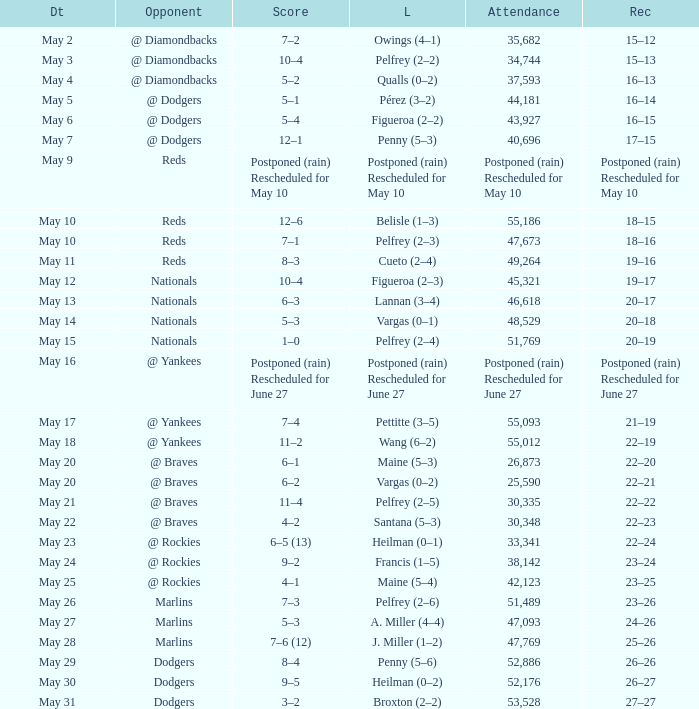Could you help me parse every detail presented in this table? {'header': ['Dt', 'Opponent', 'Score', 'L', 'Attendance', 'Rec'], 'rows': [['May 2', '@ Diamondbacks', '7–2', 'Owings (4–1)', '35,682', '15–12'], ['May 3', '@ Diamondbacks', '10–4', 'Pelfrey (2–2)', '34,744', '15–13'], ['May 4', '@ Diamondbacks', '5–2', 'Qualls (0–2)', '37,593', '16–13'], ['May 5', '@ Dodgers', '5–1', 'Pérez (3–2)', '44,181', '16–14'], ['May 6', '@ Dodgers', '5–4', 'Figueroa (2–2)', '43,927', '16–15'], ['May 7', '@ Dodgers', '12–1', 'Penny (5–3)', '40,696', '17–15'], ['May 9', 'Reds', 'Postponed (rain) Rescheduled for May 10', 'Postponed (rain) Rescheduled for May 10', 'Postponed (rain) Rescheduled for May 10', 'Postponed (rain) Rescheduled for May 10'], ['May 10', 'Reds', '12–6', 'Belisle (1–3)', '55,186', '18–15'], ['May 10', 'Reds', '7–1', 'Pelfrey (2–3)', '47,673', '18–16'], ['May 11', 'Reds', '8–3', 'Cueto (2–4)', '49,264', '19–16'], ['May 12', 'Nationals', '10–4', 'Figueroa (2–3)', '45,321', '19–17'], ['May 13', 'Nationals', '6–3', 'Lannan (3–4)', '46,618', '20–17'], ['May 14', 'Nationals', '5–3', 'Vargas (0–1)', '48,529', '20–18'], ['May 15', 'Nationals', '1–0', 'Pelfrey (2–4)', '51,769', '20–19'], ['May 16', '@ Yankees', 'Postponed (rain) Rescheduled for June 27', 'Postponed (rain) Rescheduled for June 27', 'Postponed (rain) Rescheduled for June 27', 'Postponed (rain) Rescheduled for June 27'], ['May 17', '@ Yankees', '7–4', 'Pettitte (3–5)', '55,093', '21–19'], ['May 18', '@ Yankees', '11–2', 'Wang (6–2)', '55,012', '22–19'], ['May 20', '@ Braves', '6–1', 'Maine (5–3)', '26,873', '22–20'], ['May 20', '@ Braves', '6–2', 'Vargas (0–2)', '25,590', '22–21'], ['May 21', '@ Braves', '11–4', 'Pelfrey (2–5)', '30,335', '22–22'], ['May 22', '@ Braves', '4–2', 'Santana (5–3)', '30,348', '22–23'], ['May 23', '@ Rockies', '6–5 (13)', 'Heilman (0–1)', '33,341', '22–24'], ['May 24', '@ Rockies', '9–2', 'Francis (1–5)', '38,142', '23–24'], ['May 25', '@ Rockies', '4–1', 'Maine (5–4)', '42,123', '23–25'], ['May 26', 'Marlins', '7–3', 'Pelfrey (2–6)', '51,489', '23–26'], ['May 27', 'Marlins', '5–3', 'A. Miller (4–4)', '47,093', '24–26'], ['May 28', 'Marlins', '7–6 (12)', 'J. Miller (1–2)', '47,769', '25–26'], ['May 29', 'Dodgers', '8–4', 'Penny (5–6)', '52,886', '26–26'], ['May 30', 'Dodgers', '9–5', 'Heilman (0–2)', '52,176', '26–27'], ['May 31', 'Dodgers', '3–2', 'Broxton (2–2)', '53,528', '27–27']]} Attendance of 30,335 had what record? 22–22. 